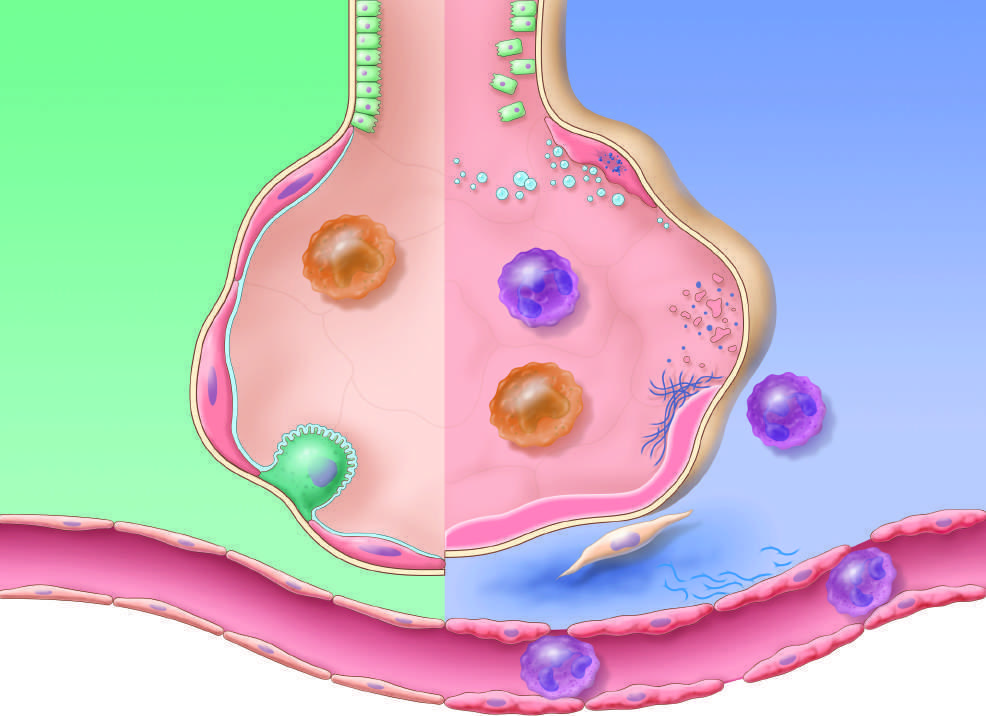what stimulates fibroblast growth and collagen deposition associated with the healing phase of injury?
Answer the question using a single word or phrase. The release of macrophage-derived fibrogenic cytokines 